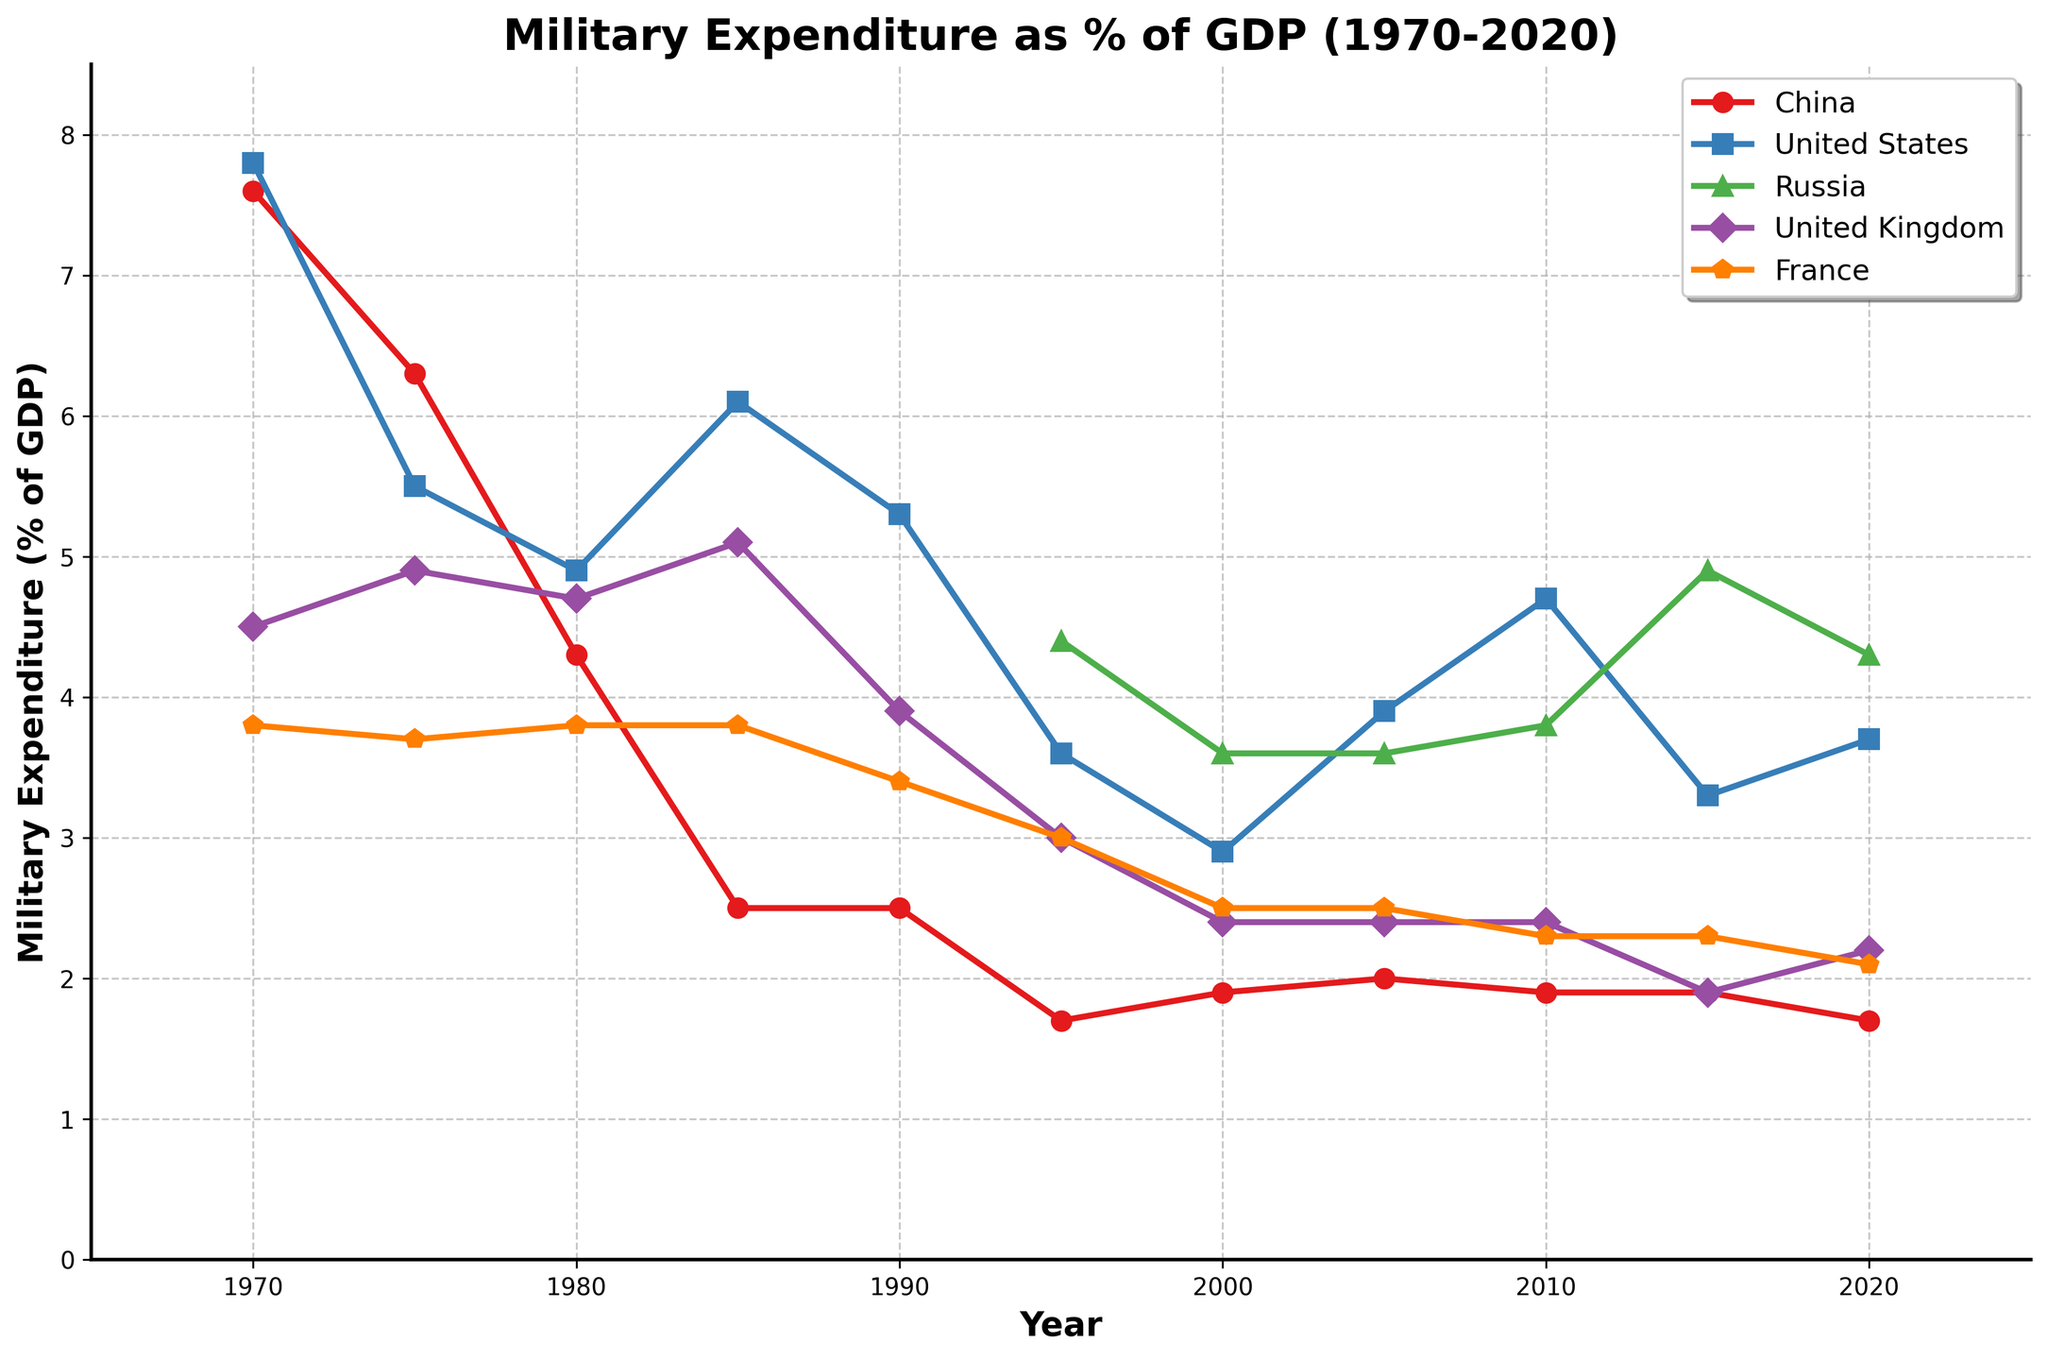What's the trend in China's military expenditure as a percentage of GDP from 1970 to 2020? Observing the line for China, it starts at a high of 7.6% in 1970, then consistently declines over the years, with a few small fluctuations, reaching around 1.7% by 2020.
Answer: It has been decreasing How does the United States' military expenditure as a percentage of GDP in 1980 compare with that of China in the same year? Looking at both lines in 1980, the United States' expenditure is approximately 4.9%, while China's is around 4.3%. Thus, the United States' expenditure is higher.
Answer: Higher Which country saw the highest percentage of GDP spent on military expenditure in 1985? Examining the data for 1985, the United States has the highest percentage with approximately 6.1% compared to China (2.5%), United Kingdom (5.1%), and France (3.8%). Russia has no data for that year.
Answer: United States What was the average military expenditure as a percentage of GDP for China and Russia in 2015? China's data point in 2015 is 1.9% and Russia's is 4.9%. The average is calculated as (1.9 + 4.9) / 2 = 3.4%.
Answer: 3.4% Was there any year when France's military expenditure as a percentage of GDP was lowest among all the listed countries? Observing the data, in 2010 France had an expenditure of 2.3%, which was lowest compared to China (1.9%), United States (4.7%), Russia (3.8%), and United Kingdom (2.4%). Similarly, in 2015 and 2020, France's percentage was not the lowest among all.
Answer: No How did the trend in military expenditure as a percentage of GDP for the United Kingdom change from 1990 to 2020? The line for the United Kingdom shows a general decline: it starts at 3.9% in 1990, drops to 2.4% in 2000 and remains around this level until 2015, then drops further to 2.2% in 2020.
Answer: It decreased Which country had a higher military expenditure as a percentage of GDP than France but lower than the United States in 1995? Checking the numbers for 1995, the United States has 3.6%, France has 3.0%, and Russia has 4.4%. The United Kingdom's expenditure is 3.0% which is equal to France's, so it doesn't count. Thus, despite Russia's highest among the available ones, overall it's the valid answer between France and the US.
Answer: Russia What is the year where China's military expenditure as a percentage of GDP was closest to that of France? China's percentage in 1980 was 4.3% and France's was 3.8%, giving a difference of 0.5%. In 1990, both had almost the same percentage: China (2.5%), France (3.4%) differences 0.9%. Finally in year 2000 France has 2.5% and china 1.9%, with deviation 0.6% so the closest for them is in 1980
Answer: 1980 